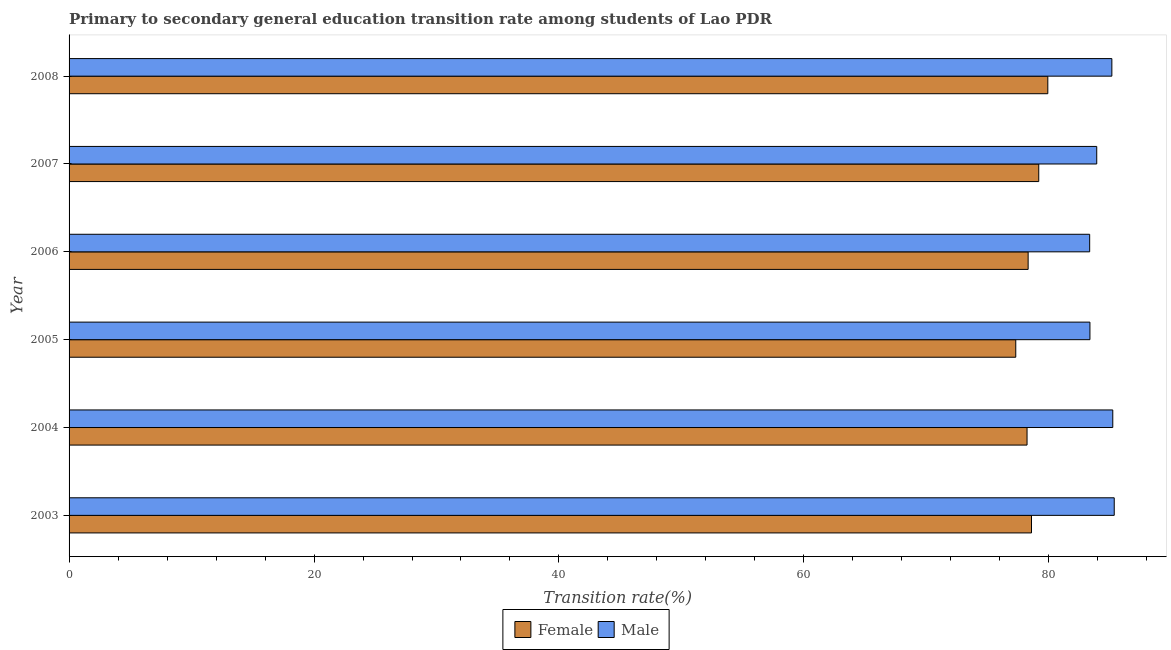How many groups of bars are there?
Offer a terse response. 6. Are the number of bars on each tick of the Y-axis equal?
Give a very brief answer. Yes. How many bars are there on the 2nd tick from the top?
Make the answer very short. 2. In how many cases, is the number of bars for a given year not equal to the number of legend labels?
Ensure brevity in your answer.  0. What is the transition rate among female students in 2005?
Your answer should be compact. 77.3. Across all years, what is the maximum transition rate among female students?
Offer a very short reply. 79.92. Across all years, what is the minimum transition rate among female students?
Provide a succinct answer. 77.3. In which year was the transition rate among male students maximum?
Keep it short and to the point. 2003. What is the total transition rate among female students in the graph?
Your response must be concise. 471.5. What is the difference between the transition rate among female students in 2007 and that in 2008?
Give a very brief answer. -0.74. What is the difference between the transition rate among female students in 2005 and the transition rate among male students in 2004?
Provide a short and direct response. -7.92. What is the average transition rate among male students per year?
Offer a very short reply. 84.38. In the year 2008, what is the difference between the transition rate among male students and transition rate among female students?
Keep it short and to the point. 5.23. What is the ratio of the transition rate among female students in 2003 to that in 2006?
Make the answer very short. 1. Is the transition rate among male students in 2006 less than that in 2007?
Offer a very short reply. Yes. What is the difference between the highest and the second highest transition rate among female students?
Offer a very short reply. 0.74. What is the difference between the highest and the lowest transition rate among male students?
Give a very brief answer. 2.01. How many years are there in the graph?
Your response must be concise. 6. What is the difference between two consecutive major ticks on the X-axis?
Your response must be concise. 20. Does the graph contain grids?
Make the answer very short. No. What is the title of the graph?
Provide a short and direct response. Primary to secondary general education transition rate among students of Lao PDR. What is the label or title of the X-axis?
Give a very brief answer. Transition rate(%). What is the Transition rate(%) of Female in 2003?
Your answer should be compact. 78.58. What is the Transition rate(%) in Male in 2003?
Make the answer very short. 85.34. What is the Transition rate(%) of Female in 2004?
Offer a very short reply. 78.22. What is the Transition rate(%) in Male in 2004?
Your answer should be very brief. 85.22. What is the Transition rate(%) in Female in 2005?
Your answer should be compact. 77.3. What is the Transition rate(%) in Male in 2005?
Keep it short and to the point. 83.36. What is the Transition rate(%) of Female in 2006?
Make the answer very short. 78.31. What is the Transition rate(%) of Male in 2006?
Offer a terse response. 83.33. What is the Transition rate(%) of Female in 2007?
Give a very brief answer. 79.18. What is the Transition rate(%) of Male in 2007?
Offer a terse response. 83.91. What is the Transition rate(%) of Female in 2008?
Your answer should be very brief. 79.92. What is the Transition rate(%) in Male in 2008?
Provide a succinct answer. 85.15. Across all years, what is the maximum Transition rate(%) of Female?
Give a very brief answer. 79.92. Across all years, what is the maximum Transition rate(%) of Male?
Provide a short and direct response. 85.34. Across all years, what is the minimum Transition rate(%) of Female?
Offer a terse response. 77.3. Across all years, what is the minimum Transition rate(%) in Male?
Provide a short and direct response. 83.33. What is the total Transition rate(%) of Female in the graph?
Offer a terse response. 471.5. What is the total Transition rate(%) in Male in the graph?
Provide a short and direct response. 506.3. What is the difference between the Transition rate(%) in Female in 2003 and that in 2004?
Give a very brief answer. 0.36. What is the difference between the Transition rate(%) in Male in 2003 and that in 2004?
Your answer should be very brief. 0.12. What is the difference between the Transition rate(%) of Female in 2003 and that in 2005?
Offer a very short reply. 1.28. What is the difference between the Transition rate(%) of Male in 2003 and that in 2005?
Your answer should be very brief. 1.98. What is the difference between the Transition rate(%) of Female in 2003 and that in 2006?
Your response must be concise. 0.27. What is the difference between the Transition rate(%) of Male in 2003 and that in 2006?
Keep it short and to the point. 2.01. What is the difference between the Transition rate(%) in Female in 2003 and that in 2007?
Ensure brevity in your answer.  -0.59. What is the difference between the Transition rate(%) in Male in 2003 and that in 2007?
Offer a terse response. 1.43. What is the difference between the Transition rate(%) in Female in 2003 and that in 2008?
Ensure brevity in your answer.  -1.33. What is the difference between the Transition rate(%) in Male in 2003 and that in 2008?
Offer a very short reply. 0.19. What is the difference between the Transition rate(%) in Female in 2004 and that in 2005?
Your answer should be compact. 0.92. What is the difference between the Transition rate(%) in Male in 2004 and that in 2005?
Your answer should be very brief. 1.86. What is the difference between the Transition rate(%) of Female in 2004 and that in 2006?
Make the answer very short. -0.09. What is the difference between the Transition rate(%) of Male in 2004 and that in 2006?
Keep it short and to the point. 1.89. What is the difference between the Transition rate(%) in Female in 2004 and that in 2007?
Provide a succinct answer. -0.96. What is the difference between the Transition rate(%) in Male in 2004 and that in 2007?
Your response must be concise. 1.31. What is the difference between the Transition rate(%) in Female in 2004 and that in 2008?
Make the answer very short. -1.7. What is the difference between the Transition rate(%) in Male in 2004 and that in 2008?
Provide a short and direct response. 0.07. What is the difference between the Transition rate(%) of Female in 2005 and that in 2006?
Your answer should be very brief. -1.01. What is the difference between the Transition rate(%) of Male in 2005 and that in 2006?
Your response must be concise. 0.02. What is the difference between the Transition rate(%) of Female in 2005 and that in 2007?
Provide a succinct answer. -1.88. What is the difference between the Transition rate(%) in Male in 2005 and that in 2007?
Keep it short and to the point. -0.55. What is the difference between the Transition rate(%) of Female in 2005 and that in 2008?
Provide a short and direct response. -2.62. What is the difference between the Transition rate(%) in Male in 2005 and that in 2008?
Provide a succinct answer. -1.79. What is the difference between the Transition rate(%) in Female in 2006 and that in 2007?
Ensure brevity in your answer.  -0.87. What is the difference between the Transition rate(%) in Male in 2006 and that in 2007?
Make the answer very short. -0.58. What is the difference between the Transition rate(%) of Female in 2006 and that in 2008?
Offer a terse response. -1.61. What is the difference between the Transition rate(%) of Male in 2006 and that in 2008?
Keep it short and to the point. -1.81. What is the difference between the Transition rate(%) in Female in 2007 and that in 2008?
Your answer should be compact. -0.74. What is the difference between the Transition rate(%) in Male in 2007 and that in 2008?
Provide a short and direct response. -1.24. What is the difference between the Transition rate(%) of Female in 2003 and the Transition rate(%) of Male in 2004?
Your answer should be very brief. -6.64. What is the difference between the Transition rate(%) in Female in 2003 and the Transition rate(%) in Male in 2005?
Your response must be concise. -4.77. What is the difference between the Transition rate(%) of Female in 2003 and the Transition rate(%) of Male in 2006?
Your response must be concise. -4.75. What is the difference between the Transition rate(%) of Female in 2003 and the Transition rate(%) of Male in 2007?
Offer a very short reply. -5.33. What is the difference between the Transition rate(%) in Female in 2003 and the Transition rate(%) in Male in 2008?
Offer a terse response. -6.56. What is the difference between the Transition rate(%) in Female in 2004 and the Transition rate(%) in Male in 2005?
Offer a terse response. -5.14. What is the difference between the Transition rate(%) of Female in 2004 and the Transition rate(%) of Male in 2006?
Give a very brief answer. -5.11. What is the difference between the Transition rate(%) in Female in 2004 and the Transition rate(%) in Male in 2007?
Ensure brevity in your answer.  -5.69. What is the difference between the Transition rate(%) of Female in 2004 and the Transition rate(%) of Male in 2008?
Your answer should be very brief. -6.93. What is the difference between the Transition rate(%) of Female in 2005 and the Transition rate(%) of Male in 2006?
Offer a very short reply. -6.03. What is the difference between the Transition rate(%) of Female in 2005 and the Transition rate(%) of Male in 2007?
Offer a very short reply. -6.61. What is the difference between the Transition rate(%) in Female in 2005 and the Transition rate(%) in Male in 2008?
Keep it short and to the point. -7.85. What is the difference between the Transition rate(%) of Female in 2006 and the Transition rate(%) of Male in 2007?
Provide a short and direct response. -5.6. What is the difference between the Transition rate(%) in Female in 2006 and the Transition rate(%) in Male in 2008?
Offer a terse response. -6.84. What is the difference between the Transition rate(%) of Female in 2007 and the Transition rate(%) of Male in 2008?
Offer a very short reply. -5.97. What is the average Transition rate(%) in Female per year?
Provide a succinct answer. 78.58. What is the average Transition rate(%) in Male per year?
Your answer should be very brief. 84.38. In the year 2003, what is the difference between the Transition rate(%) in Female and Transition rate(%) in Male?
Your answer should be compact. -6.76. In the year 2004, what is the difference between the Transition rate(%) in Female and Transition rate(%) in Male?
Give a very brief answer. -7. In the year 2005, what is the difference between the Transition rate(%) of Female and Transition rate(%) of Male?
Your response must be concise. -6.06. In the year 2006, what is the difference between the Transition rate(%) of Female and Transition rate(%) of Male?
Your response must be concise. -5.02. In the year 2007, what is the difference between the Transition rate(%) in Female and Transition rate(%) in Male?
Ensure brevity in your answer.  -4.73. In the year 2008, what is the difference between the Transition rate(%) of Female and Transition rate(%) of Male?
Your answer should be very brief. -5.23. What is the ratio of the Transition rate(%) of Male in 2003 to that in 2004?
Your answer should be compact. 1. What is the ratio of the Transition rate(%) of Female in 2003 to that in 2005?
Provide a short and direct response. 1.02. What is the ratio of the Transition rate(%) in Male in 2003 to that in 2005?
Ensure brevity in your answer.  1.02. What is the ratio of the Transition rate(%) in Male in 2003 to that in 2006?
Your answer should be very brief. 1.02. What is the ratio of the Transition rate(%) in Female in 2003 to that in 2008?
Your answer should be very brief. 0.98. What is the ratio of the Transition rate(%) in Male in 2003 to that in 2008?
Provide a succinct answer. 1. What is the ratio of the Transition rate(%) in Female in 2004 to that in 2005?
Provide a short and direct response. 1.01. What is the ratio of the Transition rate(%) of Male in 2004 to that in 2005?
Your answer should be compact. 1.02. What is the ratio of the Transition rate(%) in Male in 2004 to that in 2006?
Your answer should be compact. 1.02. What is the ratio of the Transition rate(%) in Female in 2004 to that in 2007?
Ensure brevity in your answer.  0.99. What is the ratio of the Transition rate(%) in Male in 2004 to that in 2007?
Keep it short and to the point. 1.02. What is the ratio of the Transition rate(%) in Female in 2004 to that in 2008?
Make the answer very short. 0.98. What is the ratio of the Transition rate(%) of Female in 2005 to that in 2006?
Keep it short and to the point. 0.99. What is the ratio of the Transition rate(%) in Female in 2005 to that in 2007?
Provide a succinct answer. 0.98. What is the ratio of the Transition rate(%) of Male in 2005 to that in 2007?
Provide a short and direct response. 0.99. What is the ratio of the Transition rate(%) of Female in 2005 to that in 2008?
Keep it short and to the point. 0.97. What is the ratio of the Transition rate(%) of Male in 2005 to that in 2008?
Provide a short and direct response. 0.98. What is the ratio of the Transition rate(%) in Male in 2006 to that in 2007?
Offer a terse response. 0.99. What is the ratio of the Transition rate(%) of Female in 2006 to that in 2008?
Your response must be concise. 0.98. What is the ratio of the Transition rate(%) in Male in 2006 to that in 2008?
Your answer should be very brief. 0.98. What is the ratio of the Transition rate(%) of Female in 2007 to that in 2008?
Give a very brief answer. 0.99. What is the ratio of the Transition rate(%) of Male in 2007 to that in 2008?
Ensure brevity in your answer.  0.99. What is the difference between the highest and the second highest Transition rate(%) of Female?
Provide a succinct answer. 0.74. What is the difference between the highest and the second highest Transition rate(%) of Male?
Your answer should be compact. 0.12. What is the difference between the highest and the lowest Transition rate(%) in Female?
Provide a succinct answer. 2.62. What is the difference between the highest and the lowest Transition rate(%) in Male?
Keep it short and to the point. 2.01. 